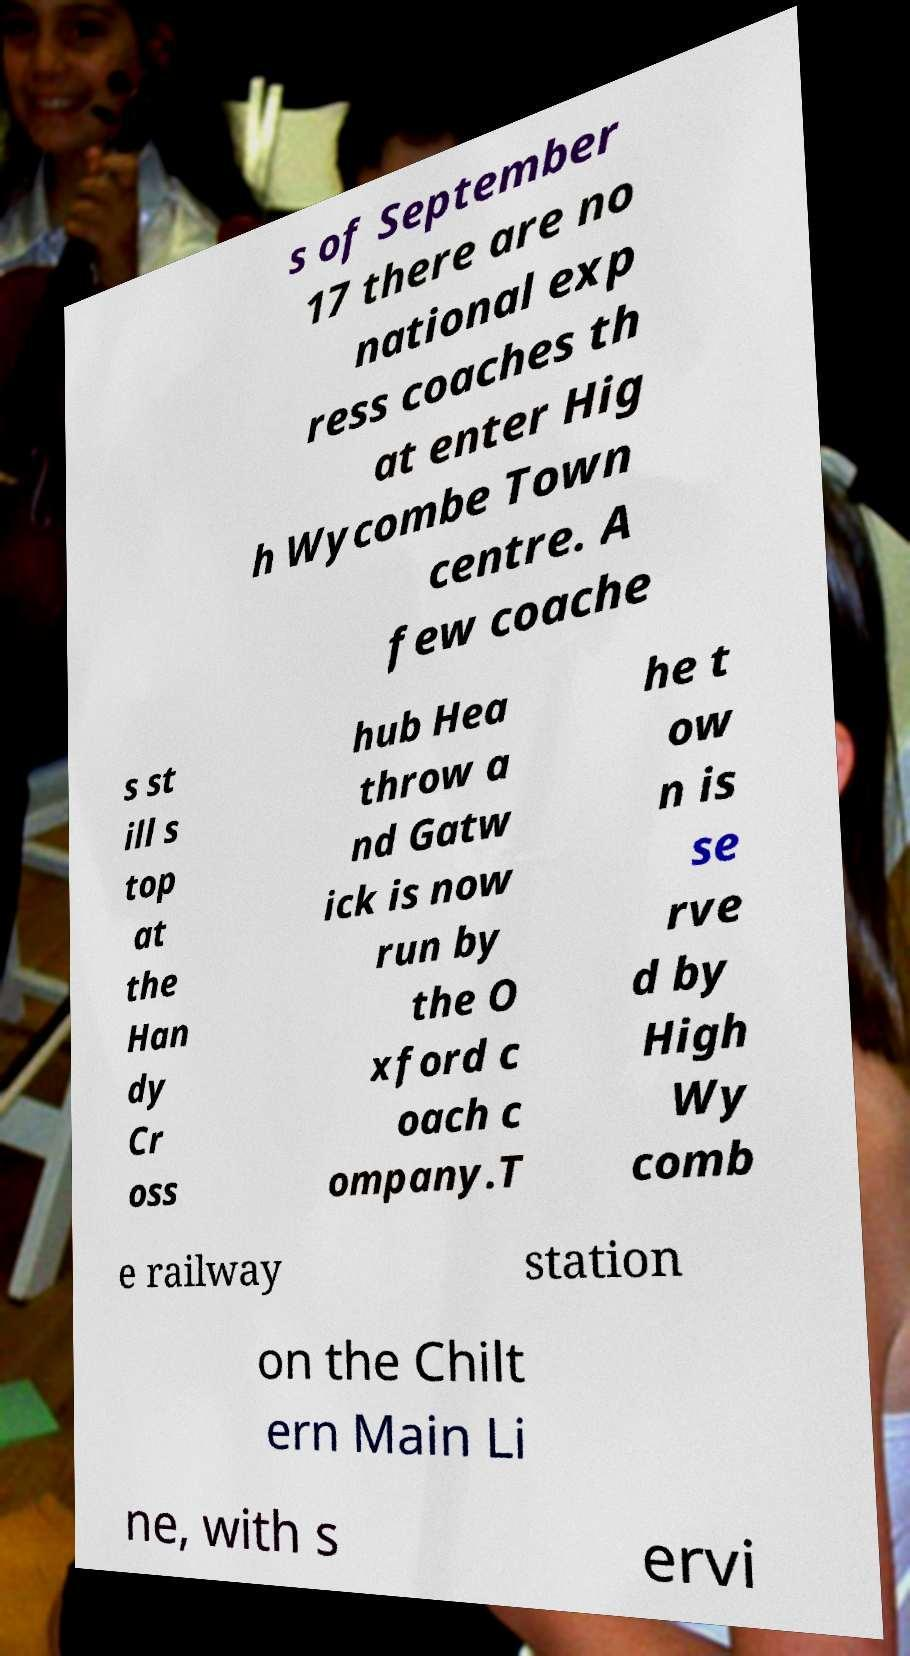Can you accurately transcribe the text from the provided image for me? s of September 17 there are no national exp ress coaches th at enter Hig h Wycombe Town centre. A few coache s st ill s top at the Han dy Cr oss hub Hea throw a nd Gatw ick is now run by the O xford c oach c ompany.T he t ow n is se rve d by High Wy comb e railway station on the Chilt ern Main Li ne, with s ervi 